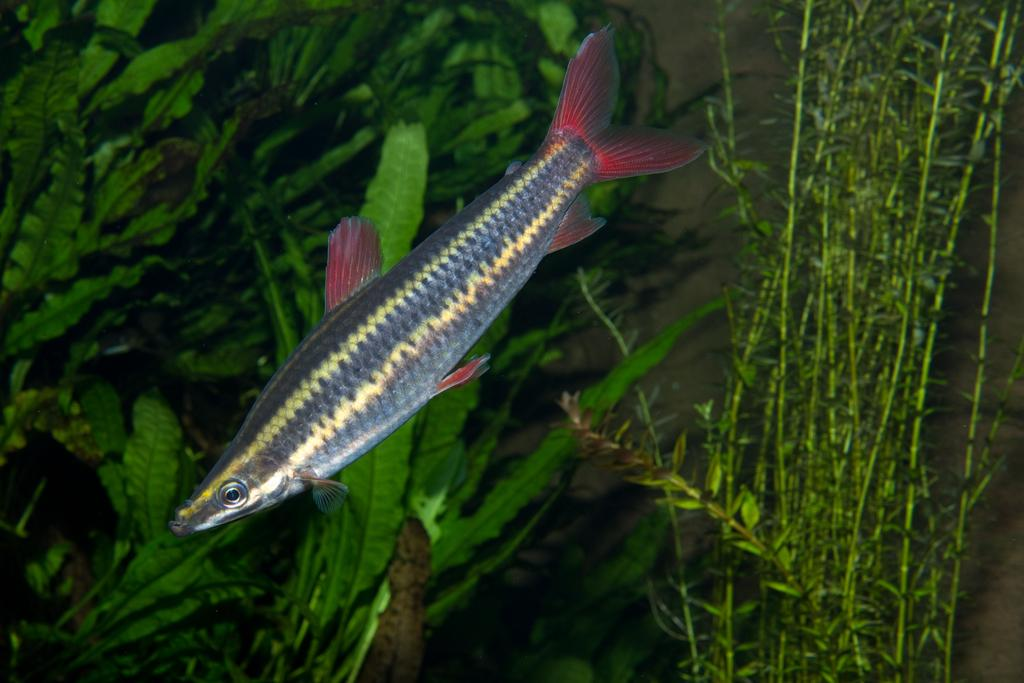What type of animal is present in the image? There is a fish in the image. What other elements can be seen in the image besides the fish? There are plants in the image. How many bikes are parked next to the fish in the image? There are no bikes present in the image; it only features a fish and plants. What color is the cannon in the image? There is no cannon present in the image. 